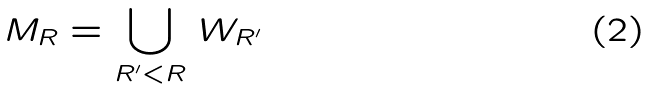Convert formula to latex. <formula><loc_0><loc_0><loc_500><loc_500>M _ { R } = \bigcup _ { R ^ { \prime } < R } \, W _ { R ^ { \prime } }</formula> 